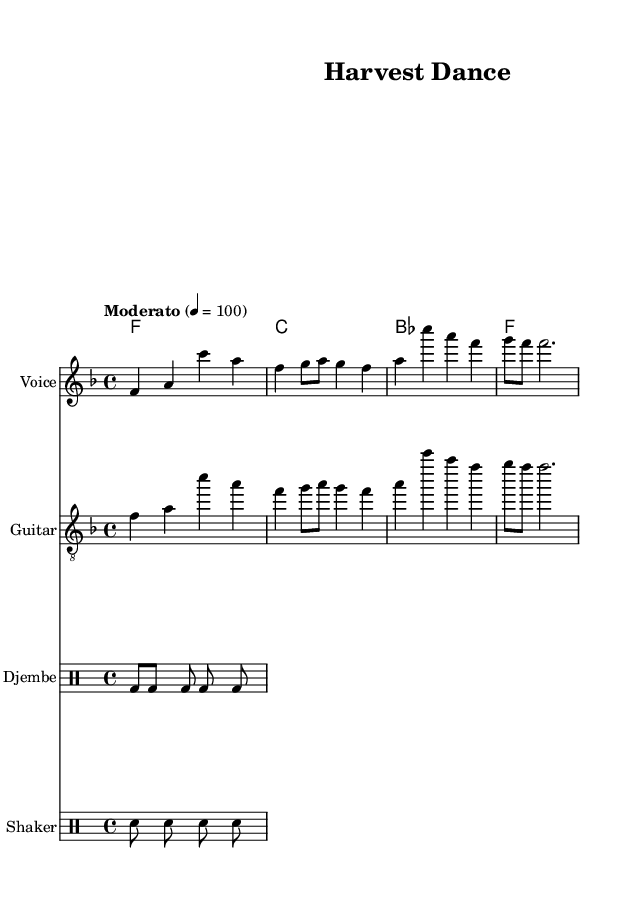What is the key signature of this music? The key signature is indicated at the beginning of the staff. It shows one flat (B♭), which means this piece is in F major.
Answer: F major What is the time signature of this piece? The time signature is placed at the beginning of the score. It shows that there are four beats in a measure, represented as 4/4.
Answer: 4/4 What is the tempo marking for this piece? The tempo is indicated as "Moderato," which suggests a moderate speed for the performance. The metronome marking of 100 indicates how many quarter notes should be played per minute.
Answer: Moderato How many measures are in the melody? By counting the measures indicated by vertical lines in the melody staff, we notice there are four measures total.
Answer: 4 What instruments are included in this arrangement? The score includes a "Voice" staff for the melody, a "Guitar" staff, and two "Drum" staffs for Djembe and Shaker, as indicated by the instrument names on the respective staves.
Answer: Voice, Guitar, Djembe, Shaker What type of rhythm does the djembe pattern represent? The djembe pattern consists of alternating bass (bd) and silence (s) sounds, showing a rhythmic pattern that is energetic, simulating the motions and grooves typical of West African-inspired folk music.
Answer: Energetic What is the primary theme in the lyrics? The lyrics focus on themes associated with planting seeds and the joys tied to the labor of farming, emphasizing hard work and connection to the earth, which reflects the folk tradition.
Answer: Planting seeds 